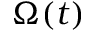Convert formula to latex. <formula><loc_0><loc_0><loc_500><loc_500>\Omega ( t )</formula> 